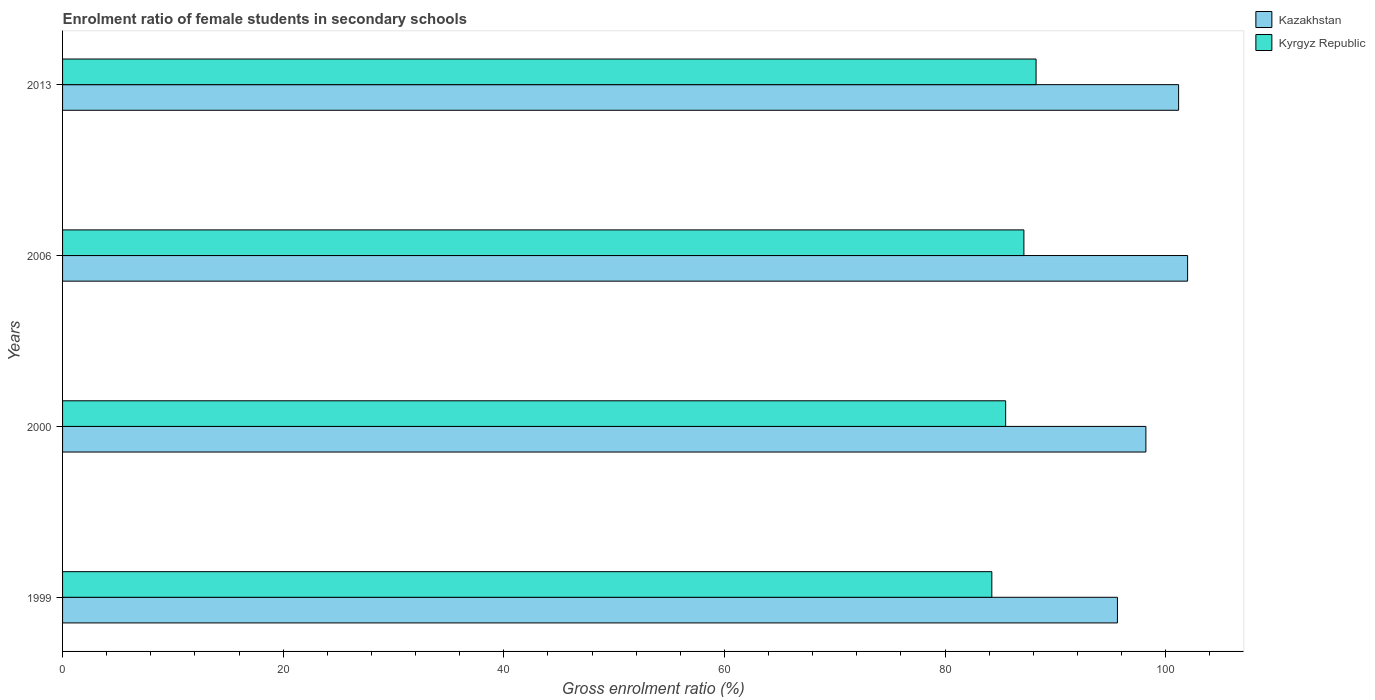How many groups of bars are there?
Keep it short and to the point. 4. Are the number of bars per tick equal to the number of legend labels?
Your answer should be very brief. Yes. Are the number of bars on each tick of the Y-axis equal?
Give a very brief answer. Yes. How many bars are there on the 3rd tick from the top?
Ensure brevity in your answer.  2. How many bars are there on the 1st tick from the bottom?
Offer a very short reply. 2. What is the label of the 4th group of bars from the top?
Give a very brief answer. 1999. In how many cases, is the number of bars for a given year not equal to the number of legend labels?
Your answer should be compact. 0. What is the enrolment ratio of female students in secondary schools in Kyrgyz Republic in 1999?
Offer a very short reply. 84.23. Across all years, what is the maximum enrolment ratio of female students in secondary schools in Kyrgyz Republic?
Keep it short and to the point. 88.25. Across all years, what is the minimum enrolment ratio of female students in secondary schools in Kazakhstan?
Ensure brevity in your answer.  95.62. In which year was the enrolment ratio of female students in secondary schools in Kazakhstan maximum?
Keep it short and to the point. 2006. What is the total enrolment ratio of female students in secondary schools in Kyrgyz Republic in the graph?
Offer a terse response. 345.11. What is the difference between the enrolment ratio of female students in secondary schools in Kazakhstan in 1999 and that in 2006?
Provide a short and direct response. -6.36. What is the difference between the enrolment ratio of female students in secondary schools in Kyrgyz Republic in 2006 and the enrolment ratio of female students in secondary schools in Kazakhstan in 1999?
Your response must be concise. -8.48. What is the average enrolment ratio of female students in secondary schools in Kyrgyz Republic per year?
Provide a short and direct response. 86.28. In the year 2006, what is the difference between the enrolment ratio of female students in secondary schools in Kyrgyz Republic and enrolment ratio of female students in secondary schools in Kazakhstan?
Make the answer very short. -14.84. What is the ratio of the enrolment ratio of female students in secondary schools in Kyrgyz Republic in 1999 to that in 2000?
Ensure brevity in your answer.  0.99. Is the enrolment ratio of female students in secondary schools in Kyrgyz Republic in 2000 less than that in 2006?
Your answer should be compact. Yes. What is the difference between the highest and the second highest enrolment ratio of female students in secondary schools in Kazakhstan?
Offer a terse response. 0.82. What is the difference between the highest and the lowest enrolment ratio of female students in secondary schools in Kyrgyz Republic?
Give a very brief answer. 4.01. In how many years, is the enrolment ratio of female students in secondary schools in Kazakhstan greater than the average enrolment ratio of female students in secondary schools in Kazakhstan taken over all years?
Your answer should be compact. 2. What does the 1st bar from the top in 1999 represents?
Offer a terse response. Kyrgyz Republic. What does the 1st bar from the bottom in 1999 represents?
Ensure brevity in your answer.  Kazakhstan. How many bars are there?
Offer a terse response. 8. How many years are there in the graph?
Offer a very short reply. 4. What is the difference between two consecutive major ticks on the X-axis?
Your answer should be compact. 20. Does the graph contain any zero values?
Make the answer very short. No. Does the graph contain grids?
Your answer should be compact. No. Where does the legend appear in the graph?
Your answer should be very brief. Top right. How are the legend labels stacked?
Offer a very short reply. Vertical. What is the title of the graph?
Provide a succinct answer. Enrolment ratio of female students in secondary schools. What is the label or title of the X-axis?
Your response must be concise. Gross enrolment ratio (%). What is the label or title of the Y-axis?
Offer a very short reply. Years. What is the Gross enrolment ratio (%) of Kazakhstan in 1999?
Offer a very short reply. 95.62. What is the Gross enrolment ratio (%) in Kyrgyz Republic in 1999?
Provide a short and direct response. 84.23. What is the Gross enrolment ratio (%) of Kazakhstan in 2000?
Offer a very short reply. 98.2. What is the Gross enrolment ratio (%) of Kyrgyz Republic in 2000?
Your answer should be compact. 85.49. What is the Gross enrolment ratio (%) of Kazakhstan in 2006?
Your answer should be compact. 101.98. What is the Gross enrolment ratio (%) of Kyrgyz Republic in 2006?
Offer a very short reply. 87.14. What is the Gross enrolment ratio (%) in Kazakhstan in 2013?
Give a very brief answer. 101.16. What is the Gross enrolment ratio (%) of Kyrgyz Republic in 2013?
Your answer should be compact. 88.25. Across all years, what is the maximum Gross enrolment ratio (%) of Kazakhstan?
Provide a succinct answer. 101.98. Across all years, what is the maximum Gross enrolment ratio (%) in Kyrgyz Republic?
Offer a very short reply. 88.25. Across all years, what is the minimum Gross enrolment ratio (%) of Kazakhstan?
Provide a short and direct response. 95.62. Across all years, what is the minimum Gross enrolment ratio (%) in Kyrgyz Republic?
Provide a short and direct response. 84.23. What is the total Gross enrolment ratio (%) in Kazakhstan in the graph?
Your answer should be very brief. 396.96. What is the total Gross enrolment ratio (%) of Kyrgyz Republic in the graph?
Ensure brevity in your answer.  345.11. What is the difference between the Gross enrolment ratio (%) of Kazakhstan in 1999 and that in 2000?
Give a very brief answer. -2.58. What is the difference between the Gross enrolment ratio (%) of Kyrgyz Republic in 1999 and that in 2000?
Your answer should be compact. -1.25. What is the difference between the Gross enrolment ratio (%) in Kazakhstan in 1999 and that in 2006?
Your answer should be very brief. -6.36. What is the difference between the Gross enrolment ratio (%) of Kyrgyz Republic in 1999 and that in 2006?
Your answer should be compact. -2.91. What is the difference between the Gross enrolment ratio (%) of Kazakhstan in 1999 and that in 2013?
Provide a short and direct response. -5.54. What is the difference between the Gross enrolment ratio (%) in Kyrgyz Republic in 1999 and that in 2013?
Your answer should be very brief. -4.01. What is the difference between the Gross enrolment ratio (%) of Kazakhstan in 2000 and that in 2006?
Make the answer very short. -3.78. What is the difference between the Gross enrolment ratio (%) of Kyrgyz Republic in 2000 and that in 2006?
Provide a succinct answer. -1.65. What is the difference between the Gross enrolment ratio (%) of Kazakhstan in 2000 and that in 2013?
Make the answer very short. -2.96. What is the difference between the Gross enrolment ratio (%) of Kyrgyz Republic in 2000 and that in 2013?
Your response must be concise. -2.76. What is the difference between the Gross enrolment ratio (%) in Kazakhstan in 2006 and that in 2013?
Your answer should be very brief. 0.82. What is the difference between the Gross enrolment ratio (%) in Kyrgyz Republic in 2006 and that in 2013?
Your response must be concise. -1.1. What is the difference between the Gross enrolment ratio (%) in Kazakhstan in 1999 and the Gross enrolment ratio (%) in Kyrgyz Republic in 2000?
Your answer should be compact. 10.13. What is the difference between the Gross enrolment ratio (%) in Kazakhstan in 1999 and the Gross enrolment ratio (%) in Kyrgyz Republic in 2006?
Your answer should be compact. 8.48. What is the difference between the Gross enrolment ratio (%) of Kazakhstan in 1999 and the Gross enrolment ratio (%) of Kyrgyz Republic in 2013?
Make the answer very short. 7.38. What is the difference between the Gross enrolment ratio (%) of Kazakhstan in 2000 and the Gross enrolment ratio (%) of Kyrgyz Republic in 2006?
Your answer should be compact. 11.06. What is the difference between the Gross enrolment ratio (%) in Kazakhstan in 2000 and the Gross enrolment ratio (%) in Kyrgyz Republic in 2013?
Ensure brevity in your answer.  9.95. What is the difference between the Gross enrolment ratio (%) of Kazakhstan in 2006 and the Gross enrolment ratio (%) of Kyrgyz Republic in 2013?
Offer a very short reply. 13.73. What is the average Gross enrolment ratio (%) in Kazakhstan per year?
Give a very brief answer. 99.24. What is the average Gross enrolment ratio (%) in Kyrgyz Republic per year?
Your response must be concise. 86.28. In the year 1999, what is the difference between the Gross enrolment ratio (%) of Kazakhstan and Gross enrolment ratio (%) of Kyrgyz Republic?
Give a very brief answer. 11.39. In the year 2000, what is the difference between the Gross enrolment ratio (%) in Kazakhstan and Gross enrolment ratio (%) in Kyrgyz Republic?
Offer a terse response. 12.71. In the year 2006, what is the difference between the Gross enrolment ratio (%) in Kazakhstan and Gross enrolment ratio (%) in Kyrgyz Republic?
Keep it short and to the point. 14.84. In the year 2013, what is the difference between the Gross enrolment ratio (%) in Kazakhstan and Gross enrolment ratio (%) in Kyrgyz Republic?
Keep it short and to the point. 12.92. What is the ratio of the Gross enrolment ratio (%) of Kazakhstan in 1999 to that in 2000?
Offer a terse response. 0.97. What is the ratio of the Gross enrolment ratio (%) of Kazakhstan in 1999 to that in 2006?
Ensure brevity in your answer.  0.94. What is the ratio of the Gross enrolment ratio (%) in Kyrgyz Republic in 1999 to that in 2006?
Your response must be concise. 0.97. What is the ratio of the Gross enrolment ratio (%) in Kazakhstan in 1999 to that in 2013?
Provide a succinct answer. 0.95. What is the ratio of the Gross enrolment ratio (%) in Kyrgyz Republic in 1999 to that in 2013?
Ensure brevity in your answer.  0.95. What is the ratio of the Gross enrolment ratio (%) in Kazakhstan in 2000 to that in 2006?
Ensure brevity in your answer.  0.96. What is the ratio of the Gross enrolment ratio (%) in Kazakhstan in 2000 to that in 2013?
Your answer should be very brief. 0.97. What is the ratio of the Gross enrolment ratio (%) of Kyrgyz Republic in 2000 to that in 2013?
Provide a succinct answer. 0.97. What is the ratio of the Gross enrolment ratio (%) of Kyrgyz Republic in 2006 to that in 2013?
Provide a succinct answer. 0.99. What is the difference between the highest and the second highest Gross enrolment ratio (%) in Kazakhstan?
Give a very brief answer. 0.82. What is the difference between the highest and the second highest Gross enrolment ratio (%) in Kyrgyz Republic?
Ensure brevity in your answer.  1.1. What is the difference between the highest and the lowest Gross enrolment ratio (%) of Kazakhstan?
Make the answer very short. 6.36. What is the difference between the highest and the lowest Gross enrolment ratio (%) in Kyrgyz Republic?
Offer a terse response. 4.01. 